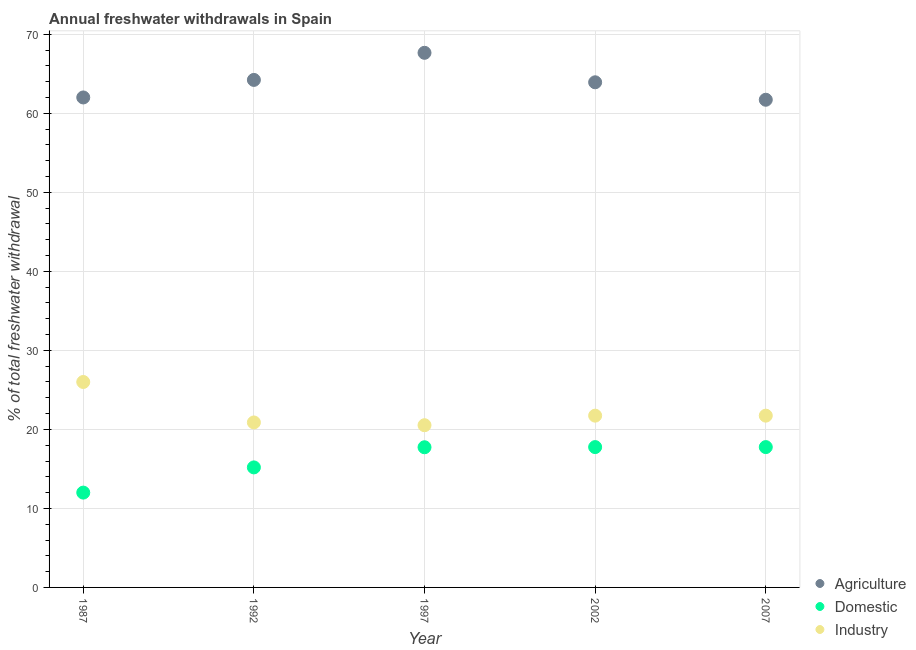How many different coloured dotlines are there?
Ensure brevity in your answer.  3. Is the number of dotlines equal to the number of legend labels?
Your response must be concise. Yes. What is the percentage of freshwater withdrawal for domestic purposes in 1997?
Your answer should be very brief. 17.74. Across all years, what is the maximum percentage of freshwater withdrawal for industry?
Your answer should be very brief. 26. Across all years, what is the minimum percentage of freshwater withdrawal for industry?
Offer a very short reply. 20.53. In which year was the percentage of freshwater withdrawal for agriculture maximum?
Ensure brevity in your answer.  1997. What is the total percentage of freshwater withdrawal for industry in the graph?
Provide a succinct answer. 110.89. What is the difference between the percentage of freshwater withdrawal for domestic purposes in 1987 and that in 1997?
Provide a succinct answer. -5.74. What is the difference between the percentage of freshwater withdrawal for domestic purposes in 1987 and the percentage of freshwater withdrawal for agriculture in 2002?
Your response must be concise. -51.93. What is the average percentage of freshwater withdrawal for industry per year?
Offer a very short reply. 22.18. In the year 2002, what is the difference between the percentage of freshwater withdrawal for agriculture and percentage of freshwater withdrawal for industry?
Make the answer very short. 42.19. What is the ratio of the percentage of freshwater withdrawal for agriculture in 1987 to that in 1992?
Your answer should be compact. 0.97. Is the percentage of freshwater withdrawal for agriculture in 1992 less than that in 2002?
Your answer should be very brief. No. What is the difference between the highest and the second highest percentage of freshwater withdrawal for domestic purposes?
Make the answer very short. 0. What is the difference between the highest and the lowest percentage of freshwater withdrawal for industry?
Give a very brief answer. 5.47. In how many years, is the percentage of freshwater withdrawal for agriculture greater than the average percentage of freshwater withdrawal for agriculture taken over all years?
Your answer should be very brief. 3. How many dotlines are there?
Provide a succinct answer. 3. How many years are there in the graph?
Provide a succinct answer. 5. Are the values on the major ticks of Y-axis written in scientific E-notation?
Your answer should be very brief. No. Does the graph contain any zero values?
Offer a very short reply. No. How many legend labels are there?
Your answer should be compact. 3. How are the legend labels stacked?
Your response must be concise. Vertical. What is the title of the graph?
Give a very brief answer. Annual freshwater withdrawals in Spain. What is the label or title of the X-axis?
Give a very brief answer. Year. What is the label or title of the Y-axis?
Offer a very short reply. % of total freshwater withdrawal. What is the % of total freshwater withdrawal in Agriculture in 1987?
Offer a terse response. 62.01. What is the % of total freshwater withdrawal in Domestic in 1987?
Provide a succinct answer. 12. What is the % of total freshwater withdrawal of Industry in 1987?
Ensure brevity in your answer.  26. What is the % of total freshwater withdrawal of Agriculture in 1992?
Provide a succinct answer. 64.23. What is the % of total freshwater withdrawal of Domestic in 1992?
Give a very brief answer. 15.19. What is the % of total freshwater withdrawal of Industry in 1992?
Give a very brief answer. 20.88. What is the % of total freshwater withdrawal in Agriculture in 1997?
Keep it short and to the point. 67.66. What is the % of total freshwater withdrawal of Domestic in 1997?
Offer a very short reply. 17.74. What is the % of total freshwater withdrawal in Industry in 1997?
Provide a succinct answer. 20.53. What is the % of total freshwater withdrawal of Agriculture in 2002?
Provide a succinct answer. 63.93. What is the % of total freshwater withdrawal of Domestic in 2002?
Ensure brevity in your answer.  17.76. What is the % of total freshwater withdrawal of Industry in 2002?
Provide a short and direct response. 21.74. What is the % of total freshwater withdrawal of Agriculture in 2007?
Provide a short and direct response. 61.72. What is the % of total freshwater withdrawal of Domestic in 2007?
Give a very brief answer. 17.76. What is the % of total freshwater withdrawal of Industry in 2007?
Provide a short and direct response. 21.74. Across all years, what is the maximum % of total freshwater withdrawal in Agriculture?
Give a very brief answer. 67.66. Across all years, what is the maximum % of total freshwater withdrawal of Domestic?
Ensure brevity in your answer.  17.76. Across all years, what is the minimum % of total freshwater withdrawal of Agriculture?
Provide a short and direct response. 61.72. Across all years, what is the minimum % of total freshwater withdrawal of Domestic?
Ensure brevity in your answer.  12. Across all years, what is the minimum % of total freshwater withdrawal in Industry?
Keep it short and to the point. 20.53. What is the total % of total freshwater withdrawal of Agriculture in the graph?
Provide a succinct answer. 319.55. What is the total % of total freshwater withdrawal of Domestic in the graph?
Your response must be concise. 80.45. What is the total % of total freshwater withdrawal in Industry in the graph?
Keep it short and to the point. 110.89. What is the difference between the % of total freshwater withdrawal of Agriculture in 1987 and that in 1992?
Make the answer very short. -2.22. What is the difference between the % of total freshwater withdrawal of Domestic in 1987 and that in 1992?
Provide a succinct answer. -3.19. What is the difference between the % of total freshwater withdrawal in Industry in 1987 and that in 1992?
Provide a succinct answer. 5.12. What is the difference between the % of total freshwater withdrawal in Agriculture in 1987 and that in 1997?
Give a very brief answer. -5.65. What is the difference between the % of total freshwater withdrawal in Domestic in 1987 and that in 1997?
Your answer should be very brief. -5.74. What is the difference between the % of total freshwater withdrawal in Industry in 1987 and that in 1997?
Ensure brevity in your answer.  5.47. What is the difference between the % of total freshwater withdrawal of Agriculture in 1987 and that in 2002?
Give a very brief answer. -1.92. What is the difference between the % of total freshwater withdrawal of Domestic in 1987 and that in 2002?
Give a very brief answer. -5.76. What is the difference between the % of total freshwater withdrawal of Industry in 1987 and that in 2002?
Keep it short and to the point. 4.26. What is the difference between the % of total freshwater withdrawal in Agriculture in 1987 and that in 2007?
Provide a short and direct response. 0.29. What is the difference between the % of total freshwater withdrawal in Domestic in 1987 and that in 2007?
Keep it short and to the point. -5.76. What is the difference between the % of total freshwater withdrawal of Industry in 1987 and that in 2007?
Offer a terse response. 4.26. What is the difference between the % of total freshwater withdrawal of Agriculture in 1992 and that in 1997?
Offer a very short reply. -3.43. What is the difference between the % of total freshwater withdrawal in Domestic in 1992 and that in 1997?
Your answer should be very brief. -2.55. What is the difference between the % of total freshwater withdrawal of Industry in 1992 and that in 1997?
Offer a terse response. 0.35. What is the difference between the % of total freshwater withdrawal of Domestic in 1992 and that in 2002?
Your response must be concise. -2.57. What is the difference between the % of total freshwater withdrawal in Industry in 1992 and that in 2002?
Keep it short and to the point. -0.86. What is the difference between the % of total freshwater withdrawal in Agriculture in 1992 and that in 2007?
Give a very brief answer. 2.51. What is the difference between the % of total freshwater withdrawal of Domestic in 1992 and that in 2007?
Make the answer very short. -2.57. What is the difference between the % of total freshwater withdrawal of Industry in 1992 and that in 2007?
Ensure brevity in your answer.  -0.86. What is the difference between the % of total freshwater withdrawal in Agriculture in 1997 and that in 2002?
Your response must be concise. 3.73. What is the difference between the % of total freshwater withdrawal in Domestic in 1997 and that in 2002?
Provide a succinct answer. -0.02. What is the difference between the % of total freshwater withdrawal in Industry in 1997 and that in 2002?
Provide a short and direct response. -1.21. What is the difference between the % of total freshwater withdrawal of Agriculture in 1997 and that in 2007?
Make the answer very short. 5.94. What is the difference between the % of total freshwater withdrawal of Domestic in 1997 and that in 2007?
Make the answer very short. -0.02. What is the difference between the % of total freshwater withdrawal in Industry in 1997 and that in 2007?
Provide a succinct answer. -1.21. What is the difference between the % of total freshwater withdrawal of Agriculture in 2002 and that in 2007?
Your response must be concise. 2.21. What is the difference between the % of total freshwater withdrawal in Domestic in 2002 and that in 2007?
Your answer should be compact. 0. What is the difference between the % of total freshwater withdrawal in Industry in 2002 and that in 2007?
Make the answer very short. 0. What is the difference between the % of total freshwater withdrawal of Agriculture in 1987 and the % of total freshwater withdrawal of Domestic in 1992?
Make the answer very short. 46.82. What is the difference between the % of total freshwater withdrawal in Agriculture in 1987 and the % of total freshwater withdrawal in Industry in 1992?
Make the answer very short. 41.13. What is the difference between the % of total freshwater withdrawal in Domestic in 1987 and the % of total freshwater withdrawal in Industry in 1992?
Offer a terse response. -8.88. What is the difference between the % of total freshwater withdrawal of Agriculture in 1987 and the % of total freshwater withdrawal of Domestic in 1997?
Your response must be concise. 44.27. What is the difference between the % of total freshwater withdrawal in Agriculture in 1987 and the % of total freshwater withdrawal in Industry in 1997?
Keep it short and to the point. 41.48. What is the difference between the % of total freshwater withdrawal of Domestic in 1987 and the % of total freshwater withdrawal of Industry in 1997?
Provide a succinct answer. -8.53. What is the difference between the % of total freshwater withdrawal in Agriculture in 1987 and the % of total freshwater withdrawal in Domestic in 2002?
Your response must be concise. 44.25. What is the difference between the % of total freshwater withdrawal of Agriculture in 1987 and the % of total freshwater withdrawal of Industry in 2002?
Your response must be concise. 40.27. What is the difference between the % of total freshwater withdrawal in Domestic in 1987 and the % of total freshwater withdrawal in Industry in 2002?
Make the answer very short. -9.74. What is the difference between the % of total freshwater withdrawal in Agriculture in 1987 and the % of total freshwater withdrawal in Domestic in 2007?
Make the answer very short. 44.25. What is the difference between the % of total freshwater withdrawal in Agriculture in 1987 and the % of total freshwater withdrawal in Industry in 2007?
Provide a short and direct response. 40.27. What is the difference between the % of total freshwater withdrawal in Domestic in 1987 and the % of total freshwater withdrawal in Industry in 2007?
Provide a short and direct response. -9.74. What is the difference between the % of total freshwater withdrawal of Agriculture in 1992 and the % of total freshwater withdrawal of Domestic in 1997?
Provide a short and direct response. 46.49. What is the difference between the % of total freshwater withdrawal in Agriculture in 1992 and the % of total freshwater withdrawal in Industry in 1997?
Keep it short and to the point. 43.7. What is the difference between the % of total freshwater withdrawal of Domestic in 1992 and the % of total freshwater withdrawal of Industry in 1997?
Ensure brevity in your answer.  -5.34. What is the difference between the % of total freshwater withdrawal in Agriculture in 1992 and the % of total freshwater withdrawal in Domestic in 2002?
Offer a terse response. 46.47. What is the difference between the % of total freshwater withdrawal in Agriculture in 1992 and the % of total freshwater withdrawal in Industry in 2002?
Ensure brevity in your answer.  42.49. What is the difference between the % of total freshwater withdrawal of Domestic in 1992 and the % of total freshwater withdrawal of Industry in 2002?
Your response must be concise. -6.55. What is the difference between the % of total freshwater withdrawal in Agriculture in 1992 and the % of total freshwater withdrawal in Domestic in 2007?
Provide a succinct answer. 46.47. What is the difference between the % of total freshwater withdrawal of Agriculture in 1992 and the % of total freshwater withdrawal of Industry in 2007?
Offer a terse response. 42.49. What is the difference between the % of total freshwater withdrawal in Domestic in 1992 and the % of total freshwater withdrawal in Industry in 2007?
Your answer should be very brief. -6.55. What is the difference between the % of total freshwater withdrawal of Agriculture in 1997 and the % of total freshwater withdrawal of Domestic in 2002?
Offer a terse response. 49.9. What is the difference between the % of total freshwater withdrawal of Agriculture in 1997 and the % of total freshwater withdrawal of Industry in 2002?
Give a very brief answer. 45.92. What is the difference between the % of total freshwater withdrawal in Agriculture in 1997 and the % of total freshwater withdrawal in Domestic in 2007?
Your response must be concise. 49.9. What is the difference between the % of total freshwater withdrawal of Agriculture in 1997 and the % of total freshwater withdrawal of Industry in 2007?
Offer a very short reply. 45.92. What is the difference between the % of total freshwater withdrawal in Domestic in 1997 and the % of total freshwater withdrawal in Industry in 2007?
Offer a terse response. -4. What is the difference between the % of total freshwater withdrawal of Agriculture in 2002 and the % of total freshwater withdrawal of Domestic in 2007?
Ensure brevity in your answer.  46.17. What is the difference between the % of total freshwater withdrawal in Agriculture in 2002 and the % of total freshwater withdrawal in Industry in 2007?
Provide a succinct answer. 42.19. What is the difference between the % of total freshwater withdrawal in Domestic in 2002 and the % of total freshwater withdrawal in Industry in 2007?
Offer a terse response. -3.98. What is the average % of total freshwater withdrawal of Agriculture per year?
Your answer should be very brief. 63.91. What is the average % of total freshwater withdrawal of Domestic per year?
Provide a short and direct response. 16.09. What is the average % of total freshwater withdrawal in Industry per year?
Ensure brevity in your answer.  22.18. In the year 1987, what is the difference between the % of total freshwater withdrawal of Agriculture and % of total freshwater withdrawal of Domestic?
Your response must be concise. 50.01. In the year 1987, what is the difference between the % of total freshwater withdrawal of Agriculture and % of total freshwater withdrawal of Industry?
Offer a terse response. 36.01. In the year 1992, what is the difference between the % of total freshwater withdrawal of Agriculture and % of total freshwater withdrawal of Domestic?
Keep it short and to the point. 49.04. In the year 1992, what is the difference between the % of total freshwater withdrawal of Agriculture and % of total freshwater withdrawal of Industry?
Your response must be concise. 43.35. In the year 1992, what is the difference between the % of total freshwater withdrawal of Domestic and % of total freshwater withdrawal of Industry?
Your answer should be very brief. -5.69. In the year 1997, what is the difference between the % of total freshwater withdrawal in Agriculture and % of total freshwater withdrawal in Domestic?
Offer a very short reply. 49.92. In the year 1997, what is the difference between the % of total freshwater withdrawal in Agriculture and % of total freshwater withdrawal in Industry?
Your answer should be compact. 47.13. In the year 1997, what is the difference between the % of total freshwater withdrawal of Domestic and % of total freshwater withdrawal of Industry?
Give a very brief answer. -2.79. In the year 2002, what is the difference between the % of total freshwater withdrawal of Agriculture and % of total freshwater withdrawal of Domestic?
Your answer should be compact. 46.17. In the year 2002, what is the difference between the % of total freshwater withdrawal of Agriculture and % of total freshwater withdrawal of Industry?
Your answer should be compact. 42.19. In the year 2002, what is the difference between the % of total freshwater withdrawal in Domestic and % of total freshwater withdrawal in Industry?
Your answer should be compact. -3.98. In the year 2007, what is the difference between the % of total freshwater withdrawal in Agriculture and % of total freshwater withdrawal in Domestic?
Ensure brevity in your answer.  43.96. In the year 2007, what is the difference between the % of total freshwater withdrawal in Agriculture and % of total freshwater withdrawal in Industry?
Offer a very short reply. 39.98. In the year 2007, what is the difference between the % of total freshwater withdrawal of Domestic and % of total freshwater withdrawal of Industry?
Provide a succinct answer. -3.98. What is the ratio of the % of total freshwater withdrawal of Agriculture in 1987 to that in 1992?
Offer a very short reply. 0.97. What is the ratio of the % of total freshwater withdrawal of Domestic in 1987 to that in 1992?
Provide a short and direct response. 0.79. What is the ratio of the % of total freshwater withdrawal of Industry in 1987 to that in 1992?
Keep it short and to the point. 1.25. What is the ratio of the % of total freshwater withdrawal in Agriculture in 1987 to that in 1997?
Offer a terse response. 0.92. What is the ratio of the % of total freshwater withdrawal in Domestic in 1987 to that in 1997?
Provide a succinct answer. 0.68. What is the ratio of the % of total freshwater withdrawal of Industry in 1987 to that in 1997?
Make the answer very short. 1.27. What is the ratio of the % of total freshwater withdrawal in Domestic in 1987 to that in 2002?
Provide a succinct answer. 0.68. What is the ratio of the % of total freshwater withdrawal in Industry in 1987 to that in 2002?
Your response must be concise. 1.2. What is the ratio of the % of total freshwater withdrawal in Agriculture in 1987 to that in 2007?
Give a very brief answer. 1. What is the ratio of the % of total freshwater withdrawal in Domestic in 1987 to that in 2007?
Offer a terse response. 0.68. What is the ratio of the % of total freshwater withdrawal in Industry in 1987 to that in 2007?
Offer a terse response. 1.2. What is the ratio of the % of total freshwater withdrawal of Agriculture in 1992 to that in 1997?
Give a very brief answer. 0.95. What is the ratio of the % of total freshwater withdrawal of Domestic in 1992 to that in 1997?
Your answer should be compact. 0.86. What is the ratio of the % of total freshwater withdrawal of Industry in 1992 to that in 1997?
Offer a terse response. 1.02. What is the ratio of the % of total freshwater withdrawal of Domestic in 1992 to that in 2002?
Provide a short and direct response. 0.86. What is the ratio of the % of total freshwater withdrawal in Industry in 1992 to that in 2002?
Offer a terse response. 0.96. What is the ratio of the % of total freshwater withdrawal in Agriculture in 1992 to that in 2007?
Offer a terse response. 1.04. What is the ratio of the % of total freshwater withdrawal of Domestic in 1992 to that in 2007?
Give a very brief answer. 0.86. What is the ratio of the % of total freshwater withdrawal in Industry in 1992 to that in 2007?
Provide a succinct answer. 0.96. What is the ratio of the % of total freshwater withdrawal of Agriculture in 1997 to that in 2002?
Your answer should be compact. 1.06. What is the ratio of the % of total freshwater withdrawal in Industry in 1997 to that in 2002?
Provide a succinct answer. 0.94. What is the ratio of the % of total freshwater withdrawal in Agriculture in 1997 to that in 2007?
Give a very brief answer. 1.1. What is the ratio of the % of total freshwater withdrawal in Industry in 1997 to that in 2007?
Offer a very short reply. 0.94. What is the ratio of the % of total freshwater withdrawal in Agriculture in 2002 to that in 2007?
Ensure brevity in your answer.  1.04. What is the difference between the highest and the second highest % of total freshwater withdrawal of Agriculture?
Provide a succinct answer. 3.43. What is the difference between the highest and the second highest % of total freshwater withdrawal of Industry?
Keep it short and to the point. 4.26. What is the difference between the highest and the lowest % of total freshwater withdrawal of Agriculture?
Give a very brief answer. 5.94. What is the difference between the highest and the lowest % of total freshwater withdrawal of Domestic?
Your response must be concise. 5.76. What is the difference between the highest and the lowest % of total freshwater withdrawal in Industry?
Provide a short and direct response. 5.47. 